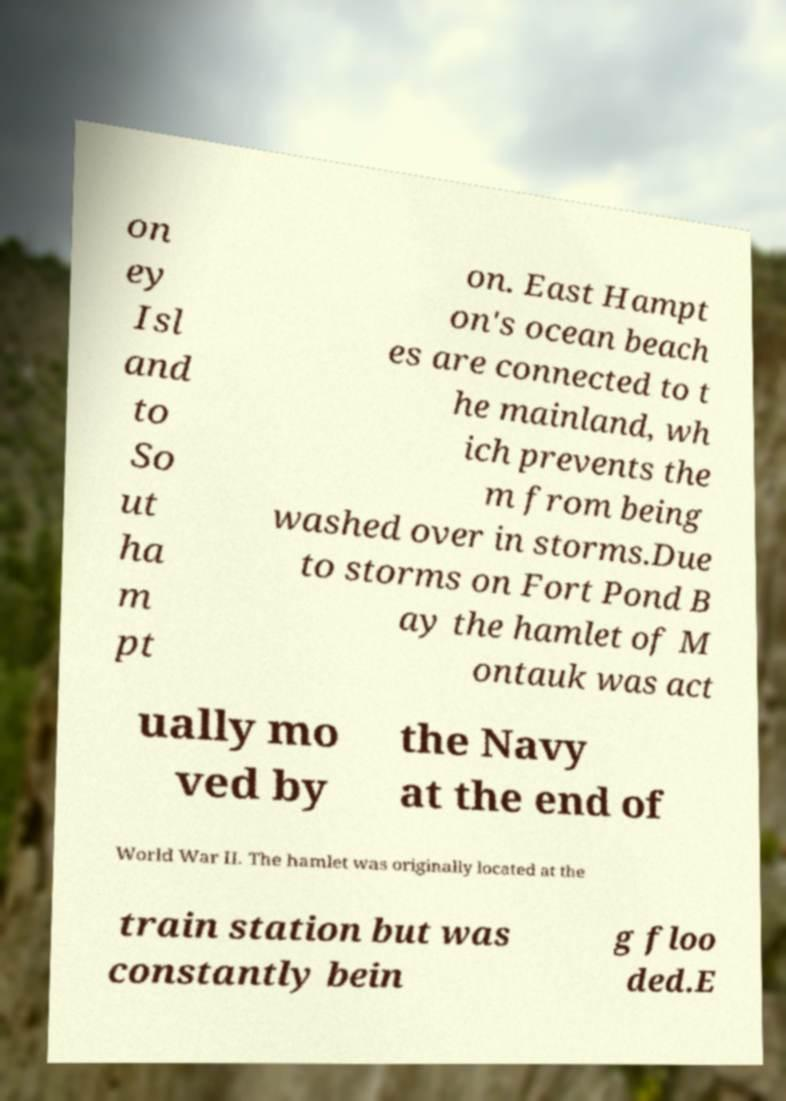What messages or text are displayed in this image? I need them in a readable, typed format. on ey Isl and to So ut ha m pt on. East Hampt on's ocean beach es are connected to t he mainland, wh ich prevents the m from being washed over in storms.Due to storms on Fort Pond B ay the hamlet of M ontauk was act ually mo ved by the Navy at the end of World War II. The hamlet was originally located at the train station but was constantly bein g floo ded.E 